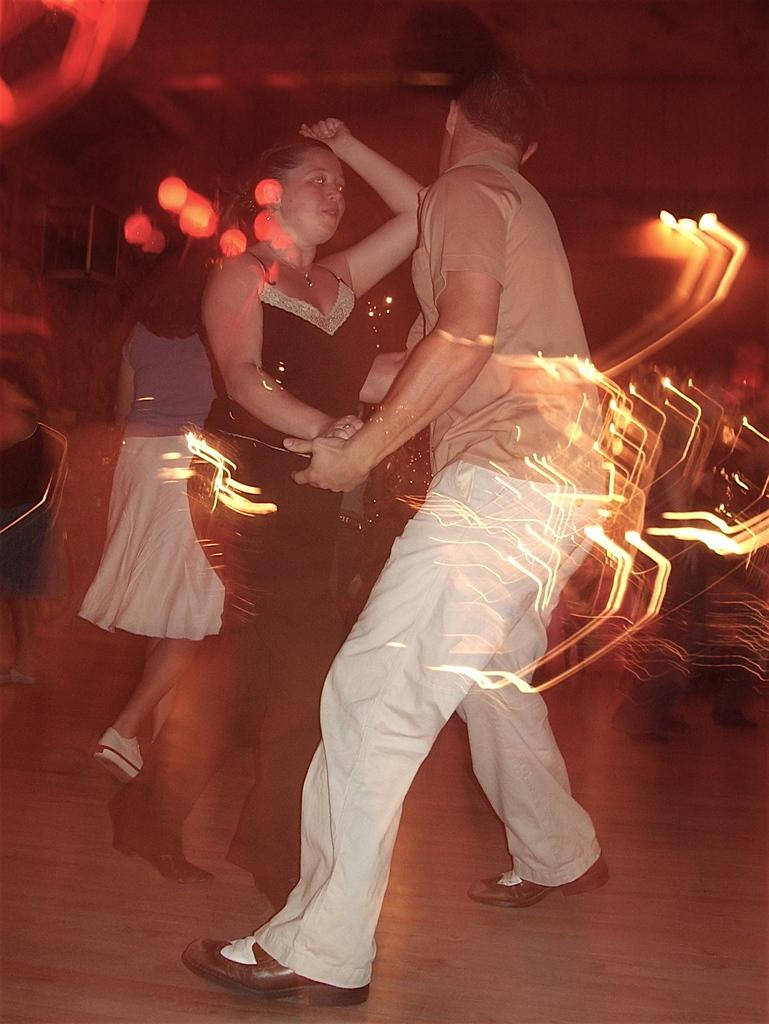What are the two persons in the image doing? The two persons in the image are dancing. Where are the dancing persons located? The dancing persons are on the floor. What is the third person in the image doing? The third person is walking. Can you describe the background of the image? The background of the image is blurred. What type of box can be seen near the seashore in the image? There is no box or seashore present in the image; it features two persons dancing and a walking person with a blurred background. 